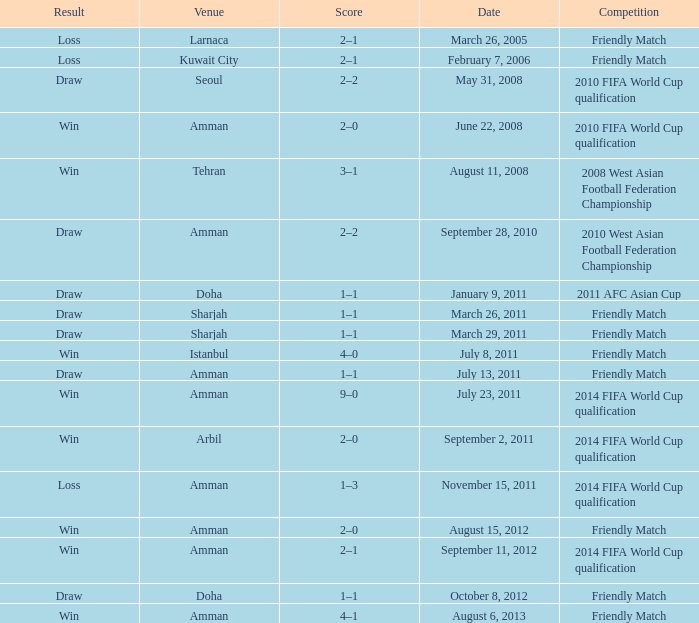WHat was the result of the friendly match that was played on october 8, 2012? Draw. 